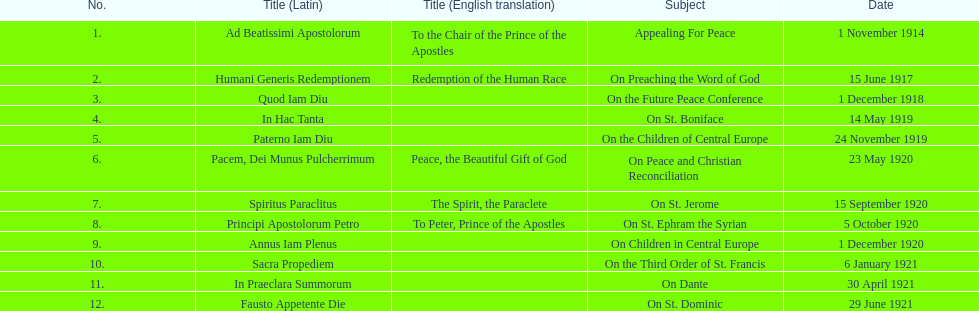Could you help me parse every detail presented in this table? {'header': ['No.', 'Title (Latin)', 'Title (English translation)', 'Subject', 'Date'], 'rows': [['1.', 'Ad Beatissimi Apostolorum', 'To the Chair of the Prince of the Apostles', 'Appealing For Peace', '1 November 1914'], ['2.', 'Humani Generis Redemptionem', 'Redemption of the Human Race', 'On Preaching the Word of God', '15 June 1917'], ['3.', 'Quod Iam Diu', '', 'On the Future Peace Conference', '1 December 1918'], ['4.', 'In Hac Tanta', '', 'On St. Boniface', '14 May 1919'], ['5.', 'Paterno Iam Diu', '', 'On the Children of Central Europe', '24 November 1919'], ['6.', 'Pacem, Dei Munus Pulcherrimum', 'Peace, the Beautiful Gift of God', 'On Peace and Christian Reconciliation', '23 May 1920'], ['7.', 'Spiritus Paraclitus', 'The Spirit, the Paraclete', 'On St. Jerome', '15 September 1920'], ['8.', 'Principi Apostolorum Petro', 'To Peter, Prince of the Apostles', 'On St. Ephram the Syrian', '5 October 1920'], ['9.', 'Annus Iam Plenus', '', 'On Children in Central Europe', '1 December 1920'], ['10.', 'Sacra Propediem', '', 'On the Third Order of St. Francis', '6 January 1921'], ['11.', 'In Praeclara Summorum', '', 'On Dante', '30 April 1921'], ['12.', 'Fausto Appetente Die', '', 'On St. Dominic', '29 June 1921']]} What is the overall count of encyclicals occurring in december? 2. 